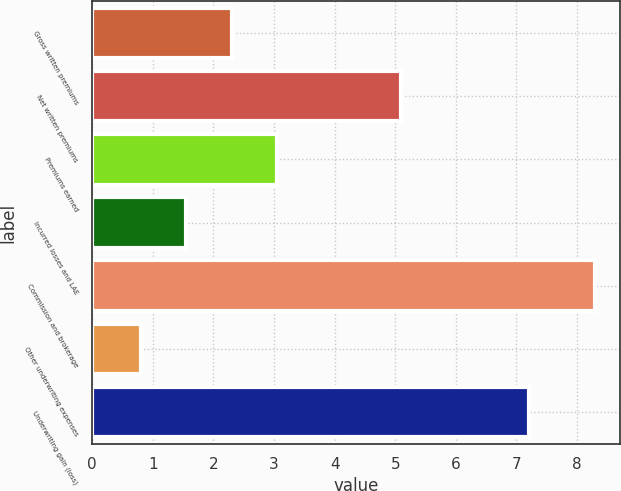Convert chart. <chart><loc_0><loc_0><loc_500><loc_500><bar_chart><fcel>Gross written premiums<fcel>Net written premiums<fcel>Premiums earned<fcel>Incurred losses and LAE<fcel>Commission and brokerage<fcel>Other underwriting expenses<fcel>Underwriting gain (loss)<nl><fcel>2.3<fcel>5.1<fcel>3.05<fcel>1.55<fcel>8.3<fcel>0.8<fcel>7.2<nl></chart> 